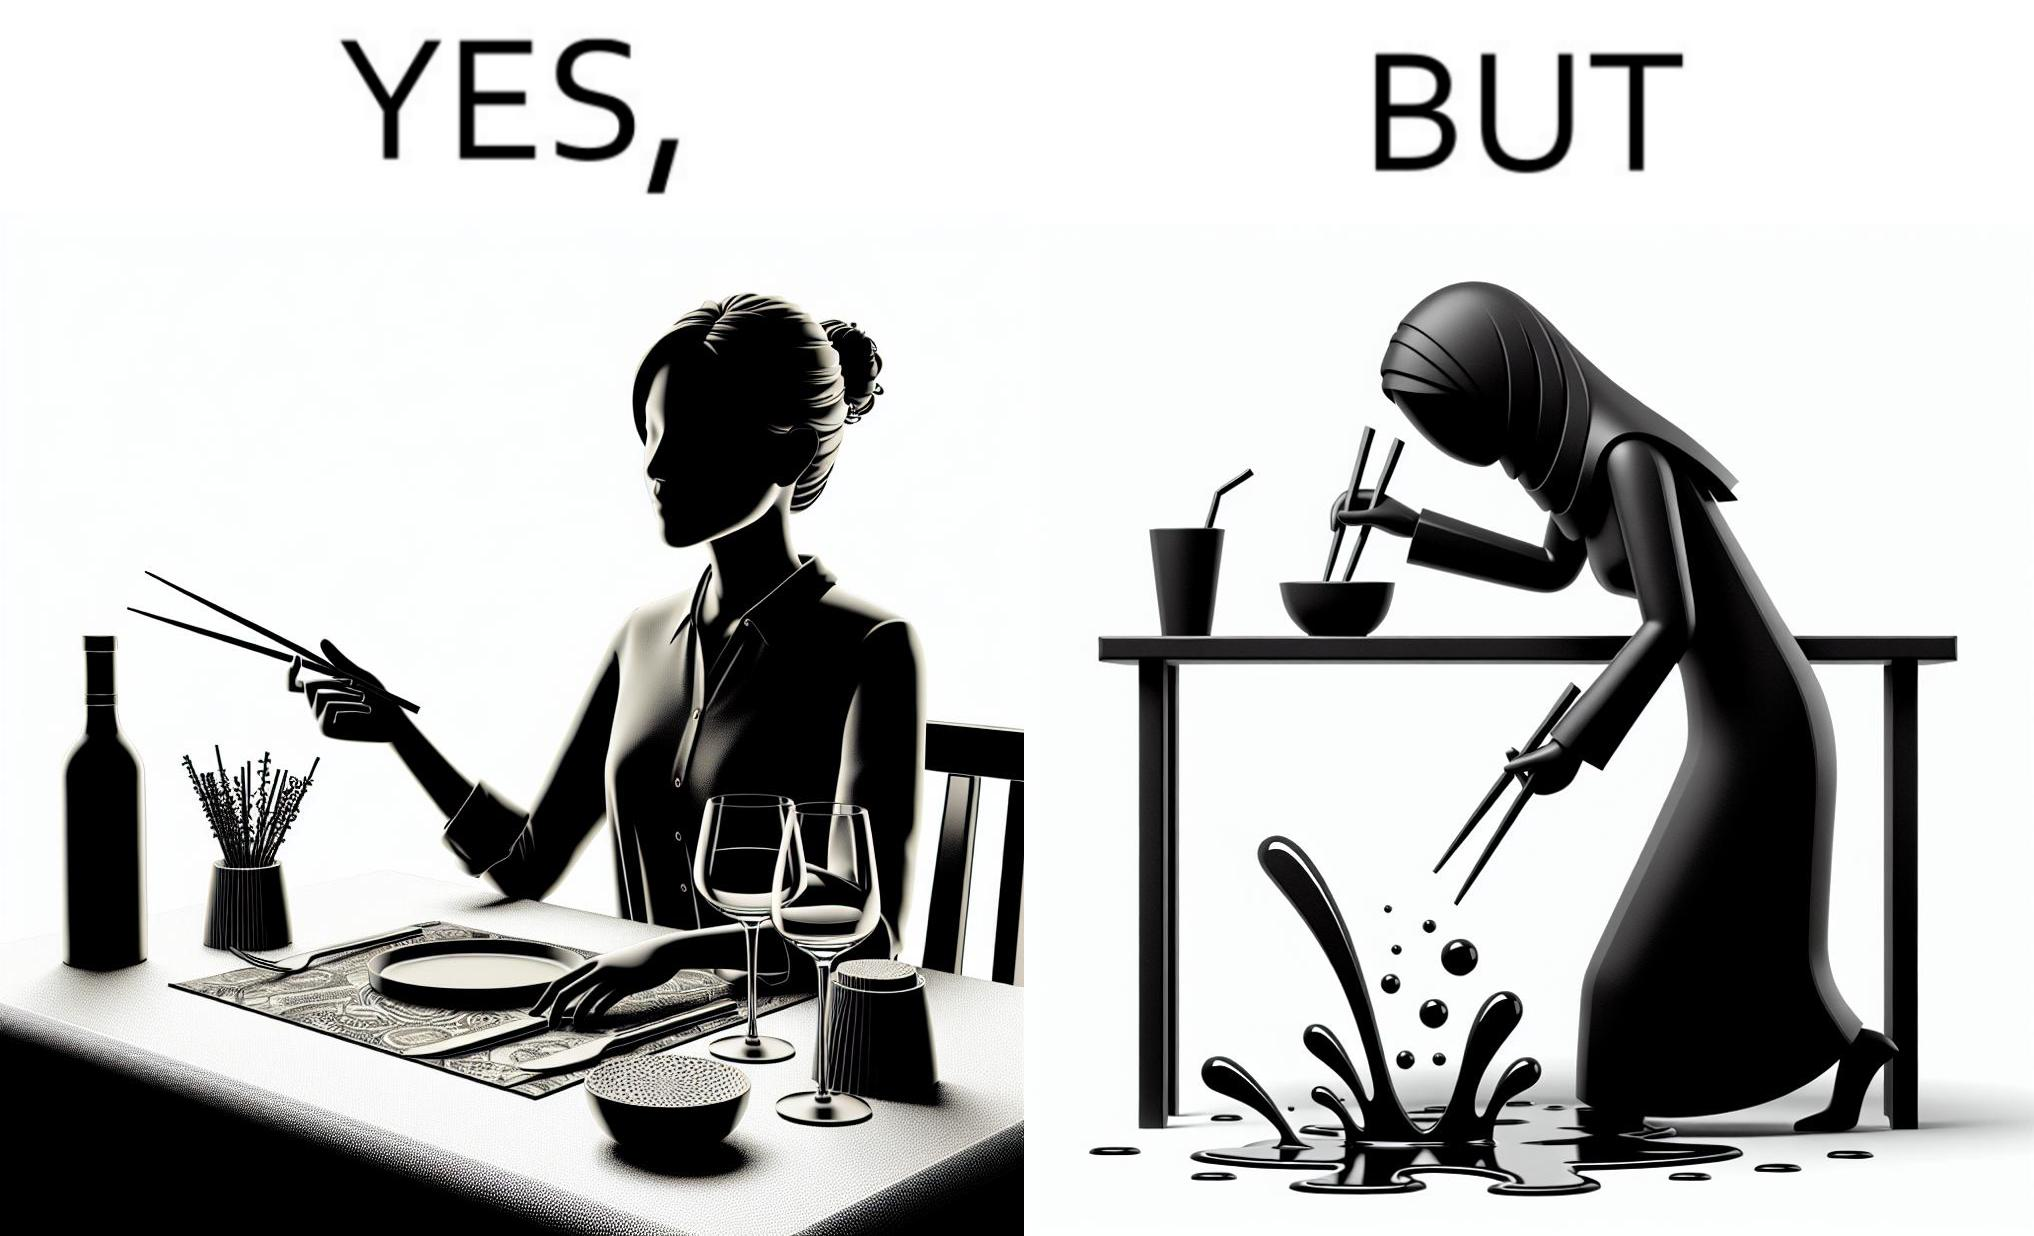Describe what you see in this image. The image is satirical because even thought the woman is not able to eat food with chopstick properly, she chooses it over fork and knife to look sophisticaed. 